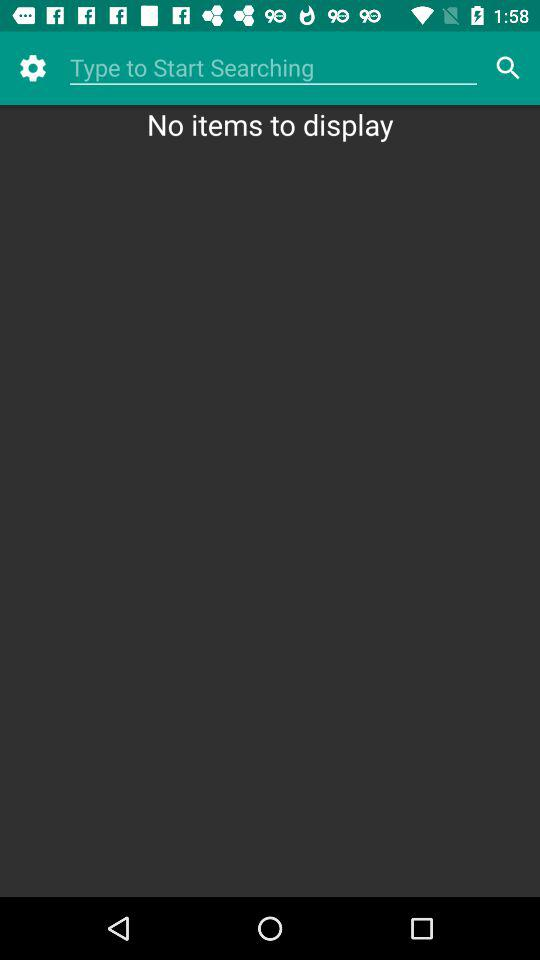Is there any items to display? There are no items to display. 